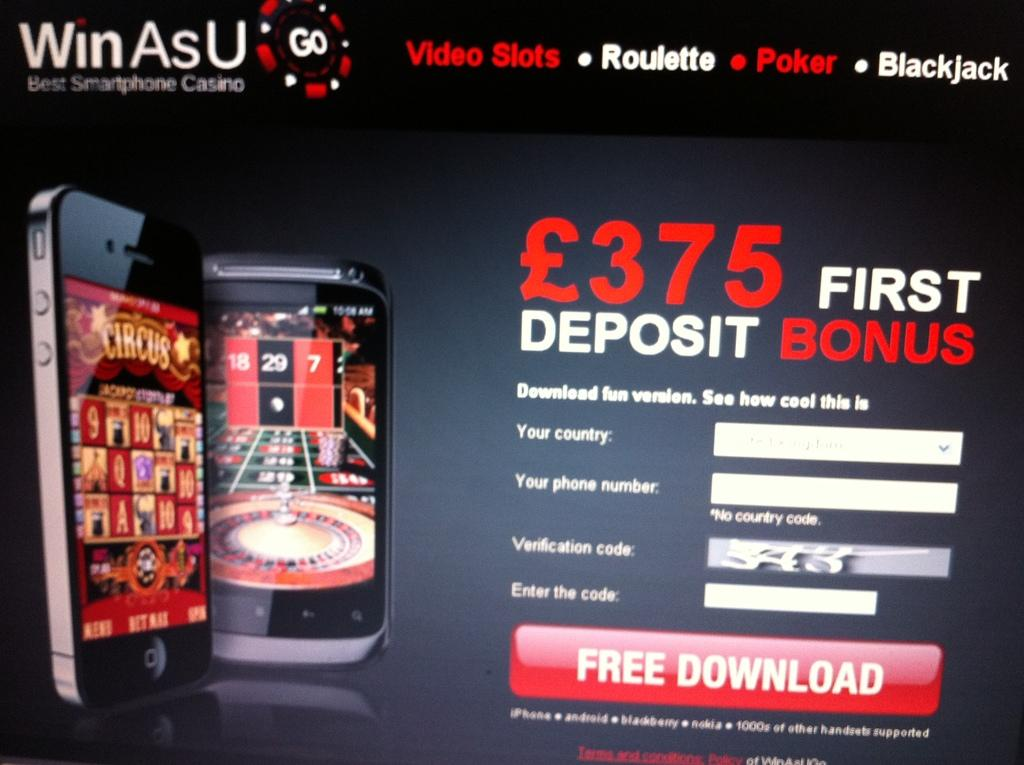Provide a one-sentence caption for the provided image. Ad for a phone app that saids $375 for the first deposit bonus. 